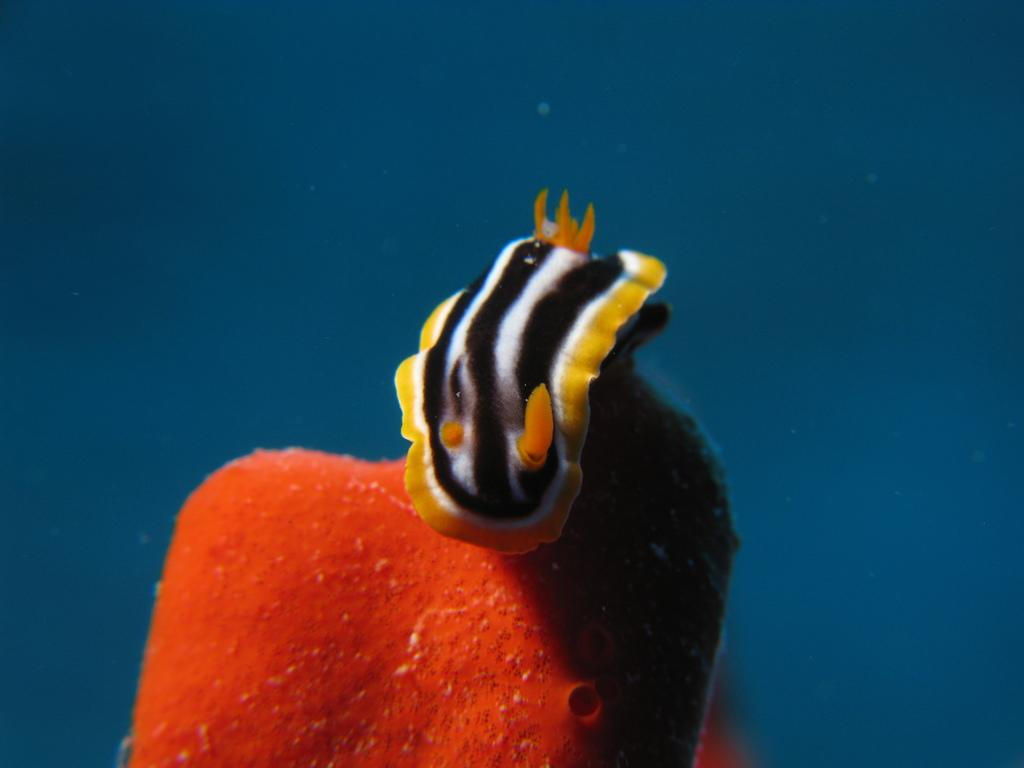What type of animal can be seen in the image? There is a sea creature in the image. Where is the sea creature located? The sea creature is in the water. What type of spoon is being used by the sea creature in the image? There is no spoon present in the image, as it features a sea creature in the water. 